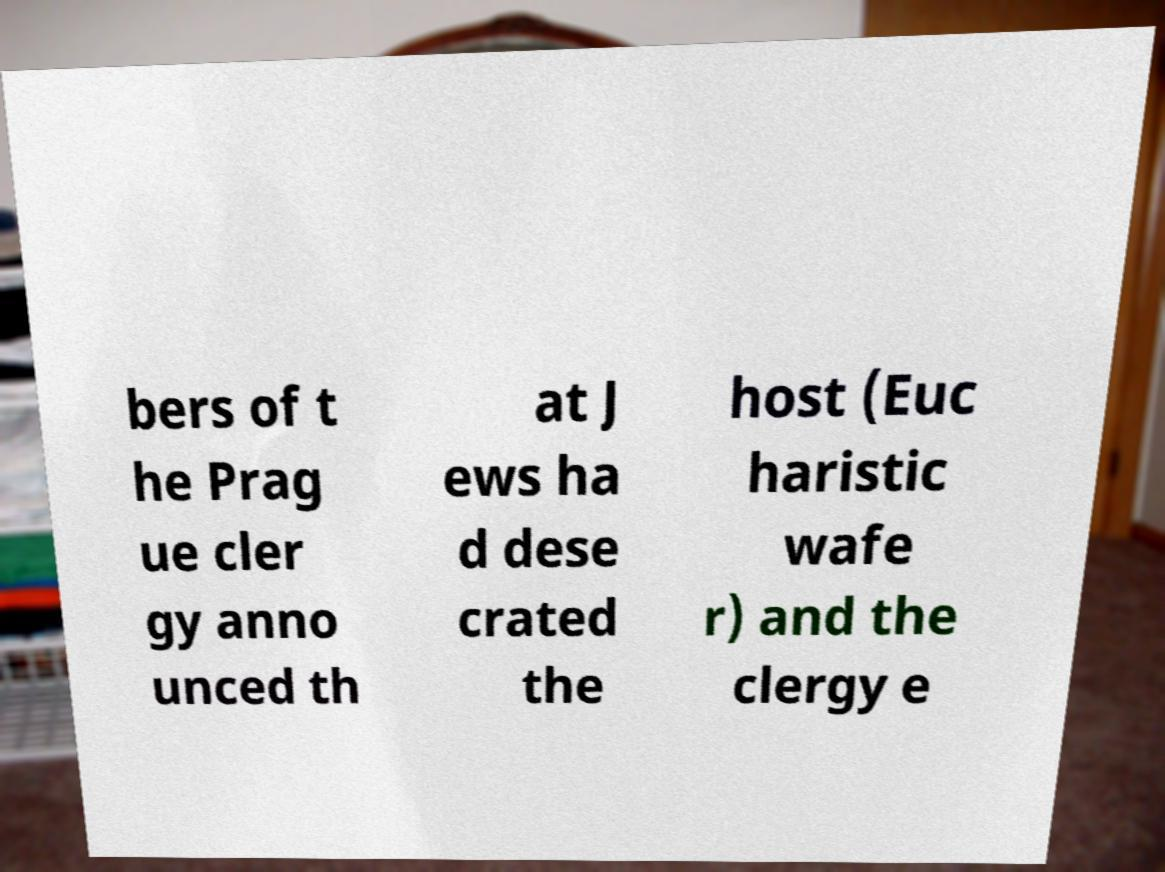I need the written content from this picture converted into text. Can you do that? bers of t he Prag ue cler gy anno unced th at J ews ha d dese crated the host (Euc haristic wafe r) and the clergy e 